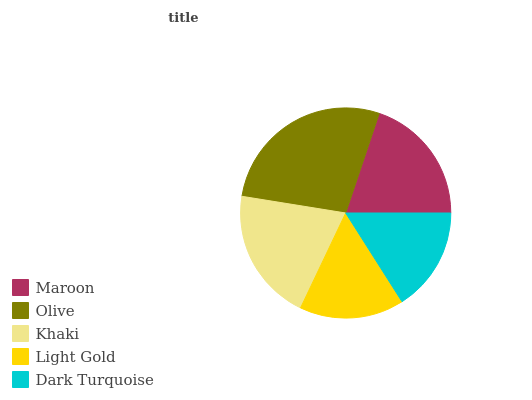Is Dark Turquoise the minimum?
Answer yes or no. Yes. Is Olive the maximum?
Answer yes or no. Yes. Is Khaki the minimum?
Answer yes or no. No. Is Khaki the maximum?
Answer yes or no. No. Is Olive greater than Khaki?
Answer yes or no. Yes. Is Khaki less than Olive?
Answer yes or no. Yes. Is Khaki greater than Olive?
Answer yes or no. No. Is Olive less than Khaki?
Answer yes or no. No. Is Maroon the high median?
Answer yes or no. Yes. Is Maroon the low median?
Answer yes or no. Yes. Is Olive the high median?
Answer yes or no. No. Is Light Gold the low median?
Answer yes or no. No. 